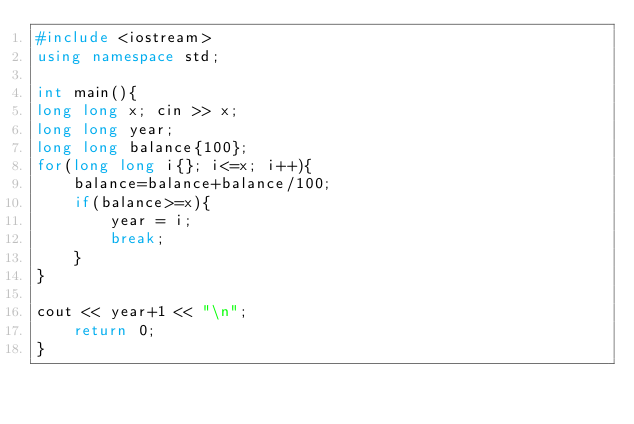<code> <loc_0><loc_0><loc_500><loc_500><_C++_>#include <iostream>
using namespace std;

int main(){
long long x; cin >> x;
long long year;
long long balance{100};
for(long long i{}; i<=x; i++){
	balance=balance+balance/100;
	if(balance>=x){
		year = i;
		break;
	}
}

cout << year+1 << "\n";
	return 0;
}


</code> 